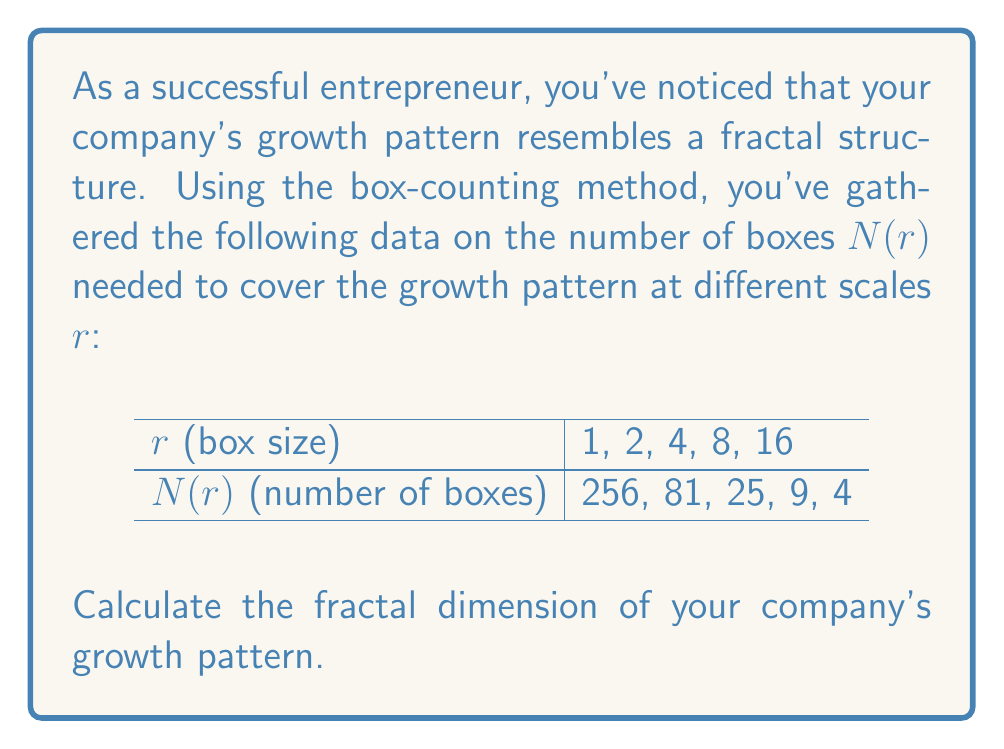Provide a solution to this math problem. To calculate the fractal dimension using the box-counting method, we'll follow these steps:

1. The fractal dimension D is given by the formula:
   
   $$D = -\lim_{r \to 0} \frac{\log N(r)}{\log r}$$

2. In practice, we can estimate D by plotting log(N(r)) against log(r) and finding the slope of the best-fit line.

3. Let's create a table with log(r) and log(N(r)):

   | r | N(r) | log(r) | log(N(r)) |
   |---|------|--------|-----------|
   | 1 | 256  | 0      | 5.5452    |
   | 2 | 81   | 0.6931 | 4.3944    |
   | 4 | 25   | 1.3863 | 3.2189    |
   | 8 | 9    | 2.0794 | 2.1972    |
   | 16| 4    | 2.7726 | 1.3863    |

4. To find the slope, we can use the least squares method:

   $$m = \frac{n\sum(xy) - \sum x \sum y}{n\sum x^2 - (\sum x)^2}$$

   Where x = log(r) and y = log(N(r))

5. Calculating the sums:
   $\sum x = 6.9314$
   $\sum y = 16.7420$
   $\sum xy = 23.7745$
   $\sum x^2 = 17.0574$
   $n = 5$

6. Plugging into the slope formula:

   $$m = \frac{5(23.7745) - (6.9314)(16.7420)}{5(17.0574) - (6.9314)^2} = -1.5821$$

7. The fractal dimension D is the negative of this slope:

   $$D = -(-1.5821) = 1.5821$$
Answer: 1.5821 